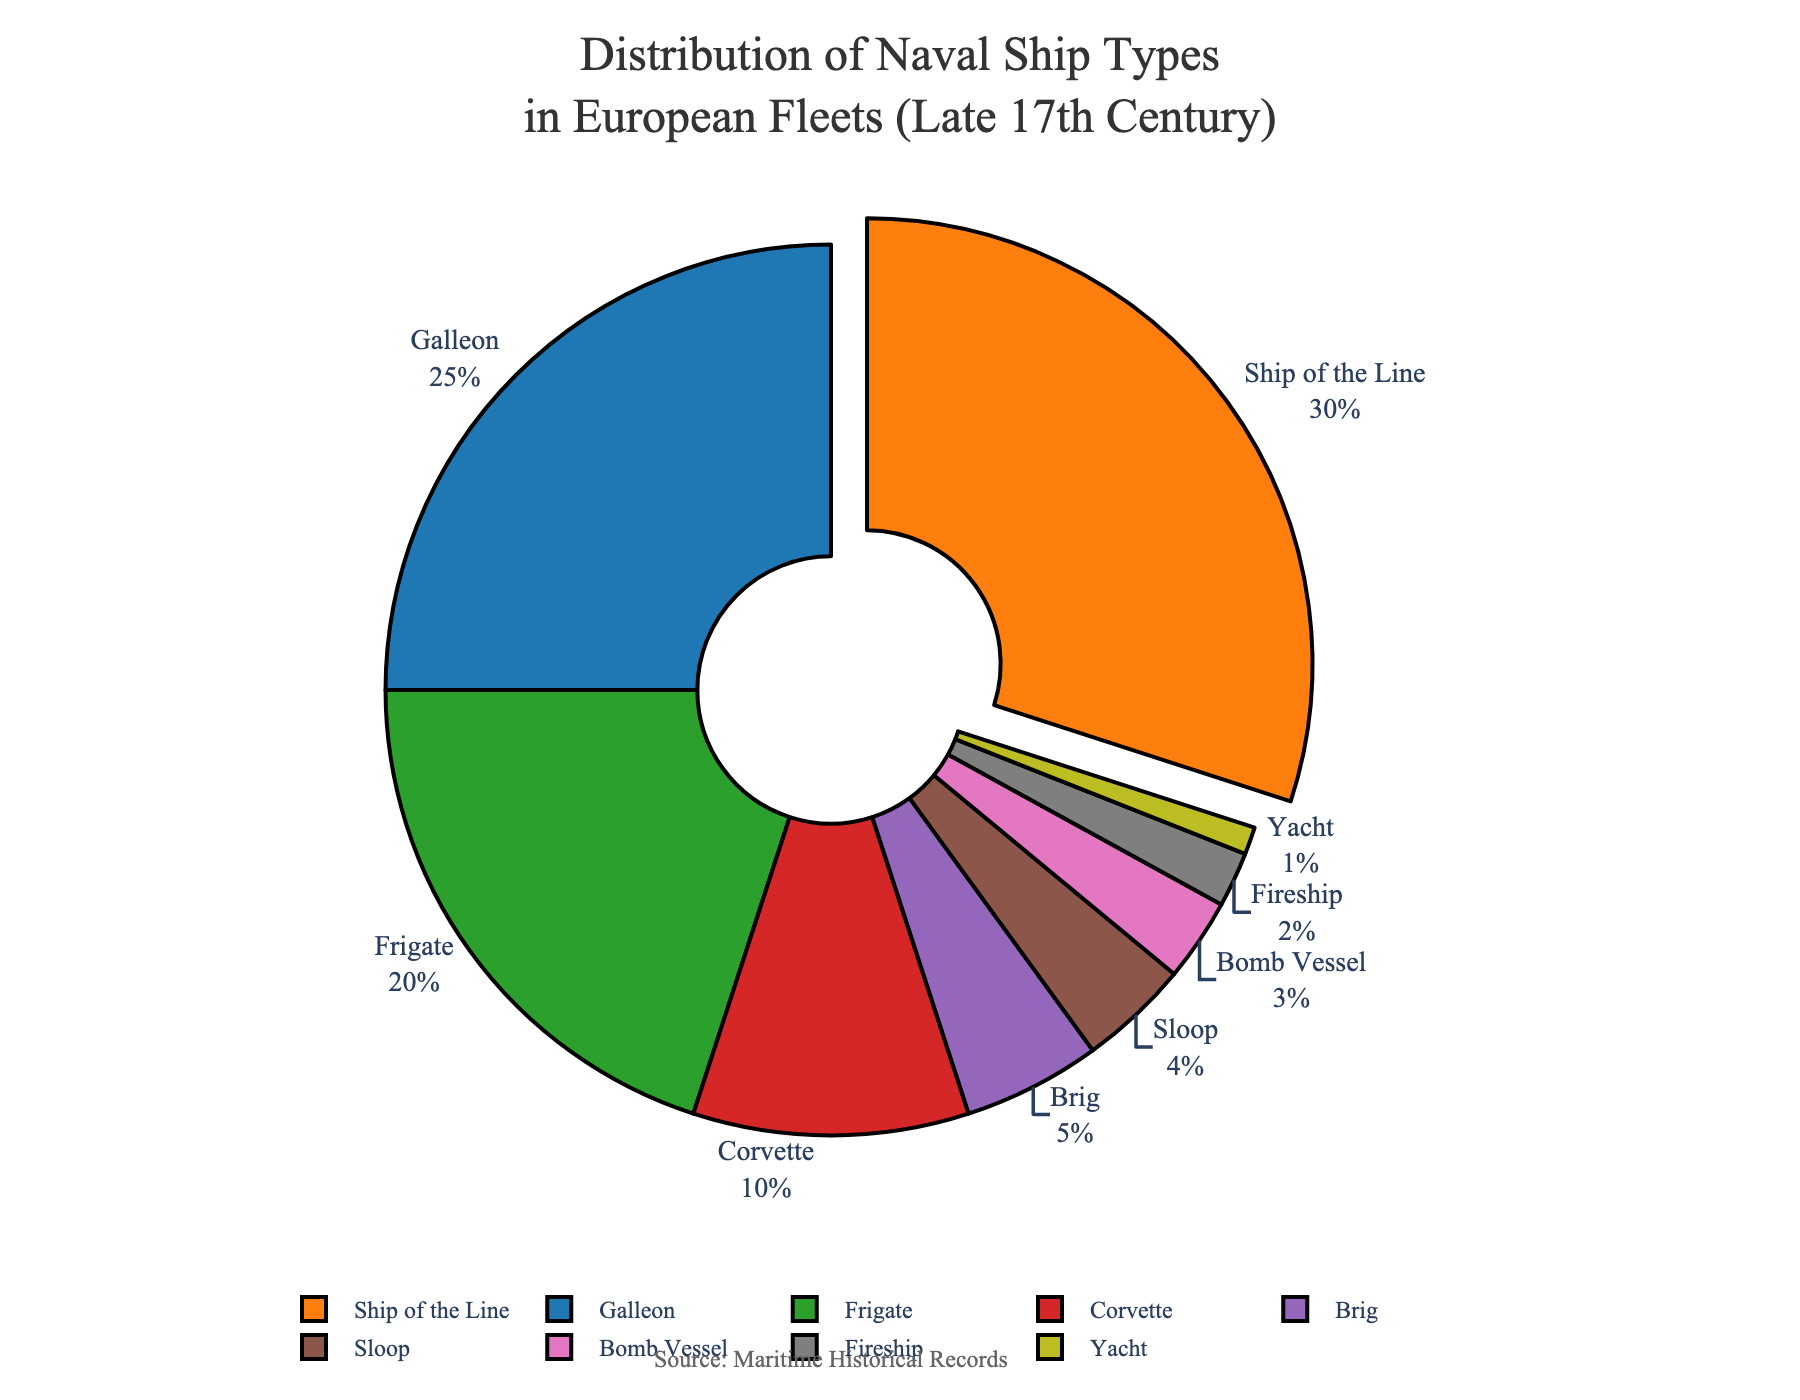Which ship type has the highest percentage in the fleet composition? To determine the ship type with the highest percentage, look for the largest section in the pie chart. The section labeled "Ship of the Line" is the largest one with 30%.
Answer: Ship of the Line What percentage of the fleet is made up of Galleons and Frigates combined? Add the percentages of Galleons (25%) and Frigates (20%). The sum is 25% + 20% = 45%.
Answer: 45% How does the proportion of Brigs compare to the proportion of Sloops? Find the percentage values of Brigs (5%) and Sloops (4%) and compare them. Brigs have a slightly higher percentage than Sloops, 5% versus 4%.
Answer: Brigs have a higher proportion What is the percentage difference between the most and least common ship types? Identify the most common ship type (Ship of the Line at 30%) and the least common one (Yacht at 1%). Subtract the smallest percentage from the largest: 30% - 1% = 29%.
Answer: 29% Which ship types collectively account for more than 50% of the fleet? Sum the percentages starting with the highest until the total exceeds 50%. Ship of the Line (30%) + Galleon (25%) = 55%. Thus, these two types account for more than 50%.
Answer: Ship of the Line and Galleon What is the relative size of the Fireship section compared to the Bomb Vessel section? Check the percentages for Fireship (2%) and Bomb Vessel (3%). The Fireship section is smaller than the Bomb Vessel section, 2% versus 3%.
Answer: Smaller If Corvettes and Brigs were combined into a single category, what would be their total percentage? Add the percentages of Corvettes (10%) and Brigs (5%). The combined percentage is 10% + 5% = 15%.
Answer: 15% Are there more Frigates or Bomb Vessels in the fleet? Compare the percentages of Frigates (20%) and Bomb Vessels (3%). Frigates make up a larger portion of the fleet than Bomb Vessels.
Answer: Frigates What is the sum of the percentages of all the ship types that have less than 10% each in the fleet? Sum the percentages of Corvette (10%), Brig (5%), Sloop (4%), Bomb Vessel (3%), Fireship (2%), and Yacht (1%). The total is 10% + 5% + 4% + 3% + 2% + 1% = 25%.
Answer: 25% Which section is visually highlighted by being pulled out from the pie chart? Identify the ship type whose section is pulled out in the pie chart. The Ship of the Line section is visually highlighted by being pulled out.
Answer: Ship of the Line 